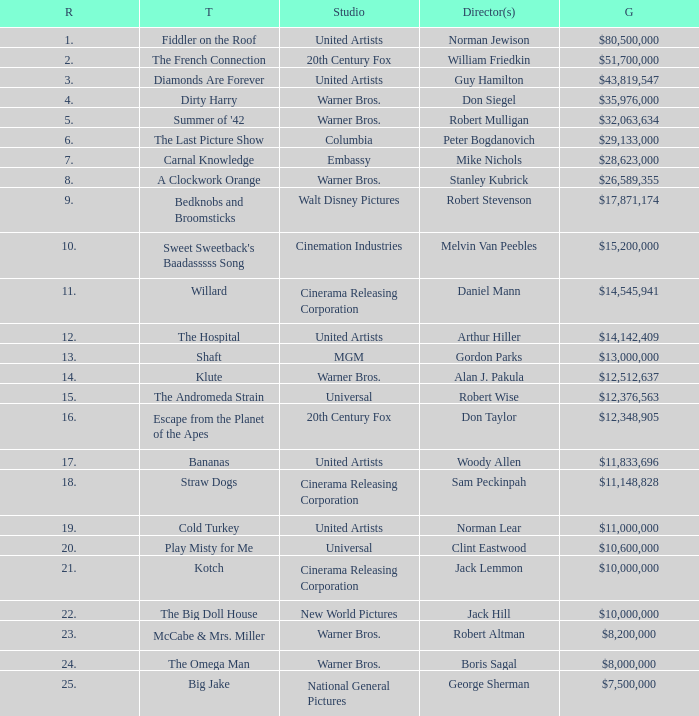What rank has a gross of $35,976,000? 4.0. 